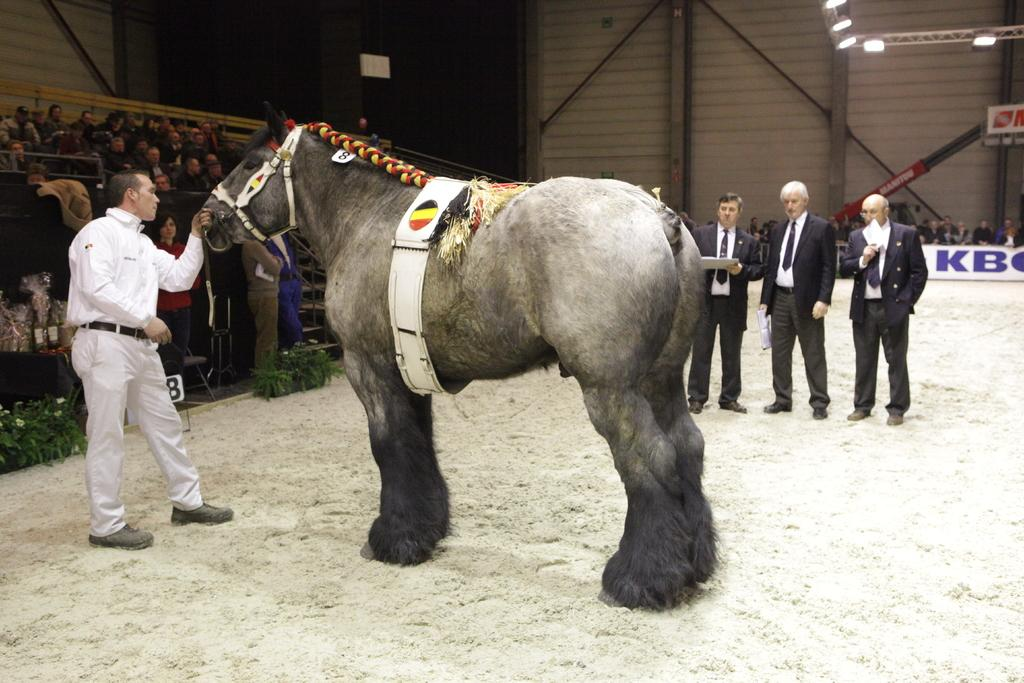What is the person in the image doing with the animal? The person is holding an animal in the image. How many people are watching the animal in the image? There are three other persons watching the animal in the image. Can you describe the background of the image? There is a wall and lights visible in the background of the image. Are there any people in the background of the image? Yes, there are people sitting in the background of the image. What type of carriage is being pulled by the animal in the image? There is no carriage present in the image; the person is simply holding the animal. What kind of ink is being used to write on the wall in the image? There is no writing or ink visible on the wall in the image. 